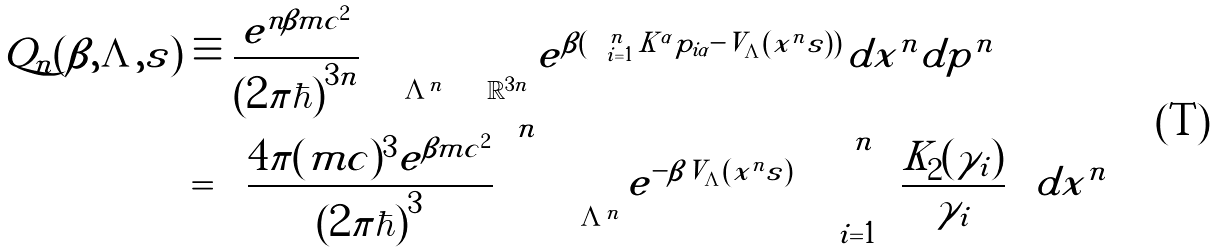<formula> <loc_0><loc_0><loc_500><loc_500>\tilde { Q } _ { n } ( \beta , \Lambda , s ) & \equiv \frac { e ^ { n \beta m c ^ { 2 } } } { ( 2 \pi \hbar { ) } ^ { 3 n } } \int _ { \Lambda ^ { n } } \int _ { \mathbb { R } ^ { 3 n } } e ^ { \beta ( \sum _ { i = 1 } ^ { n } K ^ { \alpha } p _ { i \alpha } - \tilde { V } _ { \Lambda } ( x ^ { n } | s ) ) } d x ^ { n } d p ^ { n } \\ & = \left [ \frac { 4 \pi ( m c ) ^ { 3 } e ^ { \beta m c ^ { 2 } } } { ( 2 \pi \hbar { ) } ^ { 3 } } \right ] ^ { n } \int _ { \Lambda ^ { n } } e ^ { - \beta \tilde { V } _ { \Lambda } ( x ^ { n } | s ) } \left ( \prod _ { i = 1 } ^ { n } \frac { K _ { 2 } ( \gamma _ { i } ) } { \gamma _ { i } } \right ) d x ^ { n }</formula> 